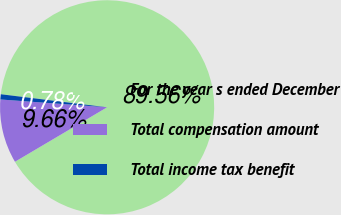<chart> <loc_0><loc_0><loc_500><loc_500><pie_chart><fcel>For the year s ended December<fcel>Total compensation amount<fcel>Total income tax benefit<nl><fcel>89.56%<fcel>9.66%<fcel>0.78%<nl></chart> 